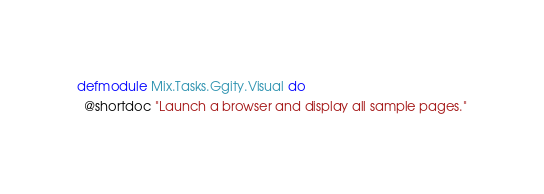Convert code to text. <code><loc_0><loc_0><loc_500><loc_500><_Elixir_>defmodule Mix.Tasks.Ggity.Visual do
  @shortdoc "Launch a browser and display all sample pages."</code> 